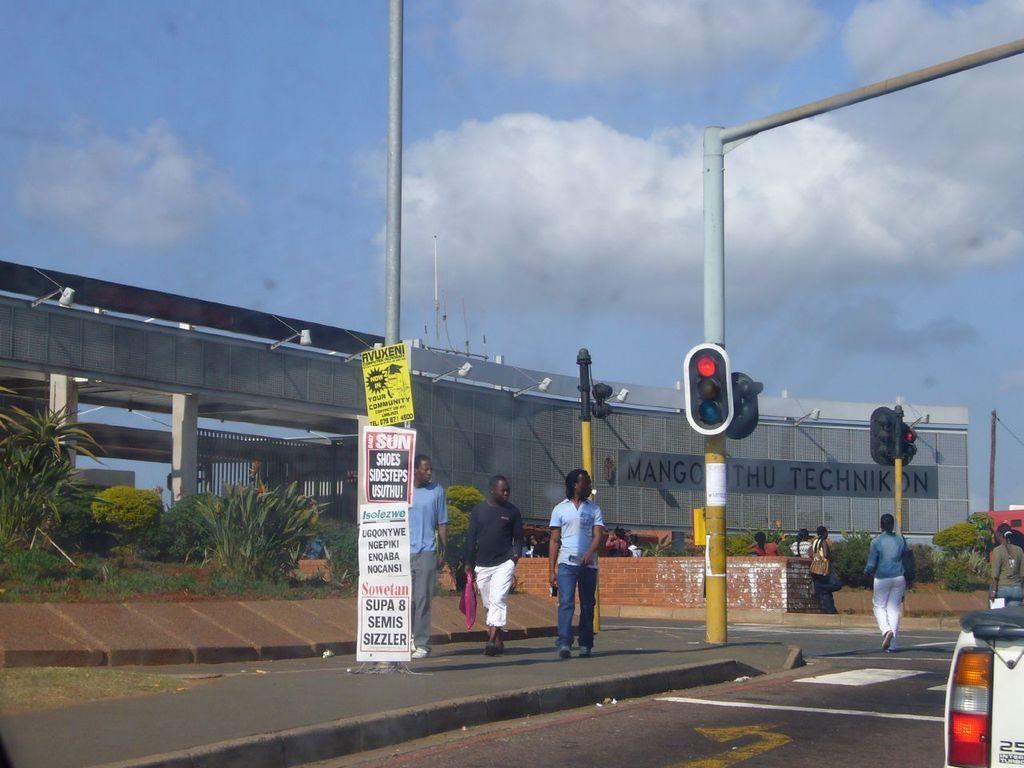Provide a one-sentence caption for the provided image. A myriad of signs sit near a stoplight that advertise Super 8 Semis. 